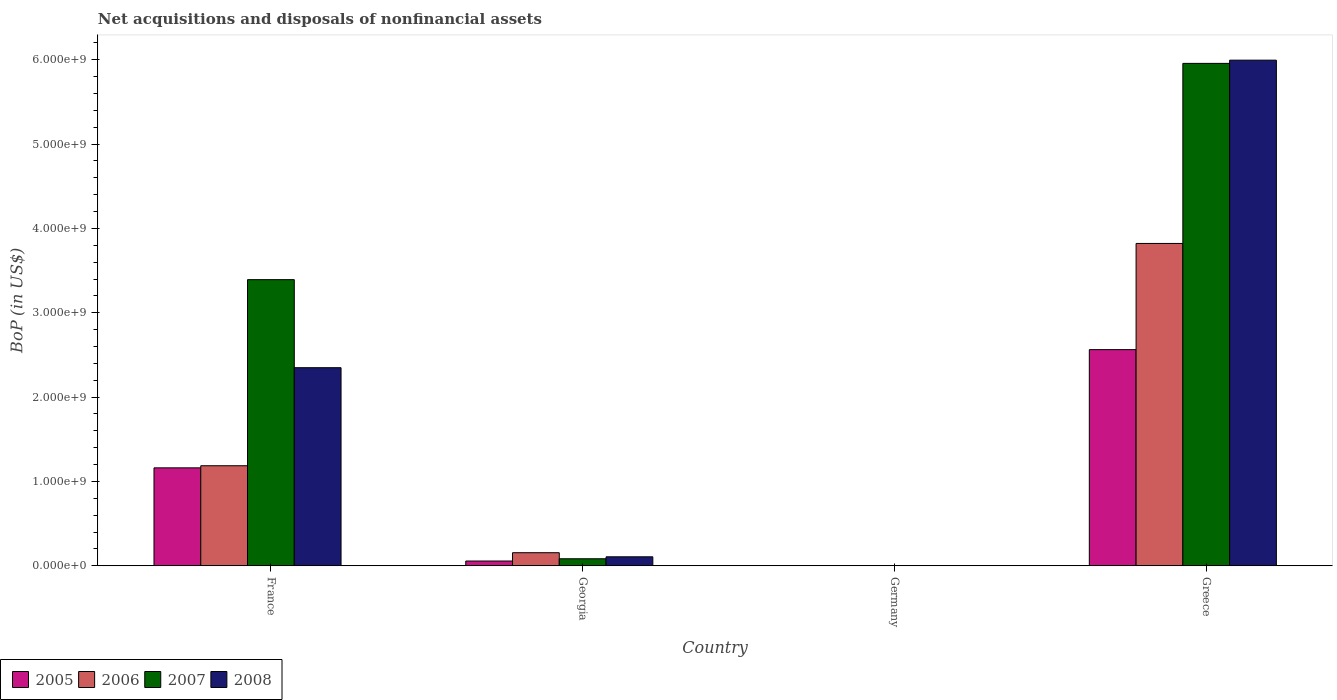Are the number of bars per tick equal to the number of legend labels?
Ensure brevity in your answer.  No. Are the number of bars on each tick of the X-axis equal?
Offer a very short reply. No. How many bars are there on the 4th tick from the right?
Your answer should be very brief. 4. What is the label of the 3rd group of bars from the left?
Provide a short and direct response. Germany. What is the Balance of Payments in 2005 in Georgia?
Make the answer very short. 5.65e+07. Across all countries, what is the maximum Balance of Payments in 2007?
Make the answer very short. 5.96e+09. In which country was the Balance of Payments in 2007 maximum?
Give a very brief answer. Greece. What is the total Balance of Payments in 2007 in the graph?
Your answer should be compact. 9.43e+09. What is the difference between the Balance of Payments in 2005 in France and that in Georgia?
Provide a short and direct response. 1.10e+09. What is the difference between the Balance of Payments in 2006 in France and the Balance of Payments in 2005 in Germany?
Ensure brevity in your answer.  1.19e+09. What is the average Balance of Payments in 2007 per country?
Give a very brief answer. 2.36e+09. What is the difference between the Balance of Payments of/in 2008 and Balance of Payments of/in 2005 in Georgia?
Ensure brevity in your answer.  5.01e+07. What is the ratio of the Balance of Payments in 2006 in Georgia to that in Greece?
Your answer should be compact. 0.04. What is the difference between the highest and the second highest Balance of Payments in 2006?
Provide a succinct answer. 1.03e+09. What is the difference between the highest and the lowest Balance of Payments in 2006?
Make the answer very short. 3.82e+09. In how many countries, is the Balance of Payments in 2006 greater than the average Balance of Payments in 2006 taken over all countries?
Keep it short and to the point. 1. How many bars are there?
Give a very brief answer. 12. Are all the bars in the graph horizontal?
Your answer should be very brief. No. How many countries are there in the graph?
Your response must be concise. 4. Are the values on the major ticks of Y-axis written in scientific E-notation?
Provide a short and direct response. Yes. Does the graph contain grids?
Offer a very short reply. No. What is the title of the graph?
Make the answer very short. Net acquisitions and disposals of nonfinancial assets. What is the label or title of the X-axis?
Your answer should be compact. Country. What is the label or title of the Y-axis?
Your answer should be very brief. BoP (in US$). What is the BoP (in US$) of 2005 in France?
Offer a terse response. 1.16e+09. What is the BoP (in US$) of 2006 in France?
Your response must be concise. 1.19e+09. What is the BoP (in US$) of 2007 in France?
Ensure brevity in your answer.  3.39e+09. What is the BoP (in US$) in 2008 in France?
Give a very brief answer. 2.35e+09. What is the BoP (in US$) in 2005 in Georgia?
Your response must be concise. 5.65e+07. What is the BoP (in US$) in 2006 in Georgia?
Your response must be concise. 1.55e+08. What is the BoP (in US$) in 2007 in Georgia?
Offer a very short reply. 8.34e+07. What is the BoP (in US$) of 2008 in Georgia?
Your answer should be compact. 1.07e+08. What is the BoP (in US$) in 2008 in Germany?
Make the answer very short. 0. What is the BoP (in US$) of 2005 in Greece?
Provide a succinct answer. 2.56e+09. What is the BoP (in US$) in 2006 in Greece?
Offer a very short reply. 3.82e+09. What is the BoP (in US$) of 2007 in Greece?
Offer a terse response. 5.96e+09. What is the BoP (in US$) in 2008 in Greece?
Offer a terse response. 6.00e+09. Across all countries, what is the maximum BoP (in US$) in 2005?
Offer a terse response. 2.56e+09. Across all countries, what is the maximum BoP (in US$) in 2006?
Your response must be concise. 3.82e+09. Across all countries, what is the maximum BoP (in US$) in 2007?
Give a very brief answer. 5.96e+09. Across all countries, what is the maximum BoP (in US$) in 2008?
Offer a terse response. 6.00e+09. Across all countries, what is the minimum BoP (in US$) in 2006?
Give a very brief answer. 0. Across all countries, what is the minimum BoP (in US$) of 2008?
Your answer should be compact. 0. What is the total BoP (in US$) in 2005 in the graph?
Provide a succinct answer. 3.78e+09. What is the total BoP (in US$) in 2006 in the graph?
Ensure brevity in your answer.  5.16e+09. What is the total BoP (in US$) in 2007 in the graph?
Make the answer very short. 9.43e+09. What is the total BoP (in US$) of 2008 in the graph?
Ensure brevity in your answer.  8.45e+09. What is the difference between the BoP (in US$) of 2005 in France and that in Georgia?
Offer a terse response. 1.10e+09. What is the difference between the BoP (in US$) in 2006 in France and that in Georgia?
Provide a short and direct response. 1.03e+09. What is the difference between the BoP (in US$) of 2007 in France and that in Georgia?
Ensure brevity in your answer.  3.31e+09. What is the difference between the BoP (in US$) in 2008 in France and that in Georgia?
Ensure brevity in your answer.  2.24e+09. What is the difference between the BoP (in US$) of 2005 in France and that in Greece?
Your answer should be compact. -1.40e+09. What is the difference between the BoP (in US$) in 2006 in France and that in Greece?
Your answer should be compact. -2.64e+09. What is the difference between the BoP (in US$) in 2007 in France and that in Greece?
Give a very brief answer. -2.56e+09. What is the difference between the BoP (in US$) of 2008 in France and that in Greece?
Make the answer very short. -3.65e+09. What is the difference between the BoP (in US$) of 2005 in Georgia and that in Greece?
Your answer should be very brief. -2.51e+09. What is the difference between the BoP (in US$) of 2006 in Georgia and that in Greece?
Your answer should be compact. -3.67e+09. What is the difference between the BoP (in US$) of 2007 in Georgia and that in Greece?
Provide a succinct answer. -5.87e+09. What is the difference between the BoP (in US$) of 2008 in Georgia and that in Greece?
Ensure brevity in your answer.  -5.89e+09. What is the difference between the BoP (in US$) of 2005 in France and the BoP (in US$) of 2006 in Georgia?
Provide a short and direct response. 1.01e+09. What is the difference between the BoP (in US$) in 2005 in France and the BoP (in US$) in 2007 in Georgia?
Provide a short and direct response. 1.08e+09. What is the difference between the BoP (in US$) of 2005 in France and the BoP (in US$) of 2008 in Georgia?
Give a very brief answer. 1.05e+09. What is the difference between the BoP (in US$) of 2006 in France and the BoP (in US$) of 2007 in Georgia?
Provide a short and direct response. 1.10e+09. What is the difference between the BoP (in US$) in 2006 in France and the BoP (in US$) in 2008 in Georgia?
Your answer should be very brief. 1.08e+09. What is the difference between the BoP (in US$) in 2007 in France and the BoP (in US$) in 2008 in Georgia?
Offer a very short reply. 3.29e+09. What is the difference between the BoP (in US$) of 2005 in France and the BoP (in US$) of 2006 in Greece?
Offer a very short reply. -2.66e+09. What is the difference between the BoP (in US$) of 2005 in France and the BoP (in US$) of 2007 in Greece?
Ensure brevity in your answer.  -4.80e+09. What is the difference between the BoP (in US$) in 2005 in France and the BoP (in US$) in 2008 in Greece?
Your response must be concise. -4.83e+09. What is the difference between the BoP (in US$) in 2006 in France and the BoP (in US$) in 2007 in Greece?
Provide a short and direct response. -4.77e+09. What is the difference between the BoP (in US$) in 2006 in France and the BoP (in US$) in 2008 in Greece?
Give a very brief answer. -4.81e+09. What is the difference between the BoP (in US$) of 2007 in France and the BoP (in US$) of 2008 in Greece?
Your response must be concise. -2.60e+09. What is the difference between the BoP (in US$) of 2005 in Georgia and the BoP (in US$) of 2006 in Greece?
Your answer should be compact. -3.77e+09. What is the difference between the BoP (in US$) of 2005 in Georgia and the BoP (in US$) of 2007 in Greece?
Keep it short and to the point. -5.90e+09. What is the difference between the BoP (in US$) in 2005 in Georgia and the BoP (in US$) in 2008 in Greece?
Offer a very short reply. -5.94e+09. What is the difference between the BoP (in US$) in 2006 in Georgia and the BoP (in US$) in 2007 in Greece?
Your response must be concise. -5.80e+09. What is the difference between the BoP (in US$) of 2006 in Georgia and the BoP (in US$) of 2008 in Greece?
Keep it short and to the point. -5.84e+09. What is the difference between the BoP (in US$) of 2007 in Georgia and the BoP (in US$) of 2008 in Greece?
Offer a very short reply. -5.91e+09. What is the average BoP (in US$) of 2005 per country?
Make the answer very short. 9.45e+08. What is the average BoP (in US$) in 2006 per country?
Make the answer very short. 1.29e+09. What is the average BoP (in US$) of 2007 per country?
Provide a succinct answer. 2.36e+09. What is the average BoP (in US$) in 2008 per country?
Offer a very short reply. 2.11e+09. What is the difference between the BoP (in US$) in 2005 and BoP (in US$) in 2006 in France?
Your response must be concise. -2.51e+07. What is the difference between the BoP (in US$) in 2005 and BoP (in US$) in 2007 in France?
Offer a terse response. -2.23e+09. What is the difference between the BoP (in US$) in 2005 and BoP (in US$) in 2008 in France?
Offer a very short reply. -1.19e+09. What is the difference between the BoP (in US$) of 2006 and BoP (in US$) of 2007 in France?
Make the answer very short. -2.21e+09. What is the difference between the BoP (in US$) in 2006 and BoP (in US$) in 2008 in France?
Your answer should be compact. -1.16e+09. What is the difference between the BoP (in US$) in 2007 and BoP (in US$) in 2008 in France?
Ensure brevity in your answer.  1.04e+09. What is the difference between the BoP (in US$) of 2005 and BoP (in US$) of 2006 in Georgia?
Provide a short and direct response. -9.86e+07. What is the difference between the BoP (in US$) in 2005 and BoP (in US$) in 2007 in Georgia?
Your response must be concise. -2.69e+07. What is the difference between the BoP (in US$) in 2005 and BoP (in US$) in 2008 in Georgia?
Provide a succinct answer. -5.01e+07. What is the difference between the BoP (in US$) in 2006 and BoP (in US$) in 2007 in Georgia?
Your response must be concise. 7.17e+07. What is the difference between the BoP (in US$) in 2006 and BoP (in US$) in 2008 in Georgia?
Make the answer very short. 4.85e+07. What is the difference between the BoP (in US$) of 2007 and BoP (in US$) of 2008 in Georgia?
Ensure brevity in your answer.  -2.32e+07. What is the difference between the BoP (in US$) in 2005 and BoP (in US$) in 2006 in Greece?
Give a very brief answer. -1.26e+09. What is the difference between the BoP (in US$) in 2005 and BoP (in US$) in 2007 in Greece?
Offer a very short reply. -3.39e+09. What is the difference between the BoP (in US$) in 2005 and BoP (in US$) in 2008 in Greece?
Your answer should be very brief. -3.43e+09. What is the difference between the BoP (in US$) of 2006 and BoP (in US$) of 2007 in Greece?
Give a very brief answer. -2.14e+09. What is the difference between the BoP (in US$) in 2006 and BoP (in US$) in 2008 in Greece?
Offer a terse response. -2.17e+09. What is the difference between the BoP (in US$) in 2007 and BoP (in US$) in 2008 in Greece?
Offer a very short reply. -3.82e+07. What is the ratio of the BoP (in US$) in 2005 in France to that in Georgia?
Keep it short and to the point. 20.56. What is the ratio of the BoP (in US$) of 2006 in France to that in Georgia?
Your response must be concise. 7.65. What is the ratio of the BoP (in US$) of 2007 in France to that in Georgia?
Your answer should be very brief. 40.68. What is the ratio of the BoP (in US$) in 2008 in France to that in Georgia?
Keep it short and to the point. 22.03. What is the ratio of the BoP (in US$) in 2005 in France to that in Greece?
Your response must be concise. 0.45. What is the ratio of the BoP (in US$) in 2006 in France to that in Greece?
Ensure brevity in your answer.  0.31. What is the ratio of the BoP (in US$) of 2007 in France to that in Greece?
Keep it short and to the point. 0.57. What is the ratio of the BoP (in US$) of 2008 in France to that in Greece?
Offer a very short reply. 0.39. What is the ratio of the BoP (in US$) in 2005 in Georgia to that in Greece?
Provide a short and direct response. 0.02. What is the ratio of the BoP (in US$) in 2006 in Georgia to that in Greece?
Provide a succinct answer. 0.04. What is the ratio of the BoP (in US$) in 2007 in Georgia to that in Greece?
Ensure brevity in your answer.  0.01. What is the ratio of the BoP (in US$) in 2008 in Georgia to that in Greece?
Give a very brief answer. 0.02. What is the difference between the highest and the second highest BoP (in US$) of 2005?
Your answer should be very brief. 1.40e+09. What is the difference between the highest and the second highest BoP (in US$) of 2006?
Offer a very short reply. 2.64e+09. What is the difference between the highest and the second highest BoP (in US$) of 2007?
Your answer should be very brief. 2.56e+09. What is the difference between the highest and the second highest BoP (in US$) in 2008?
Offer a very short reply. 3.65e+09. What is the difference between the highest and the lowest BoP (in US$) in 2005?
Make the answer very short. 2.56e+09. What is the difference between the highest and the lowest BoP (in US$) of 2006?
Make the answer very short. 3.82e+09. What is the difference between the highest and the lowest BoP (in US$) in 2007?
Give a very brief answer. 5.96e+09. What is the difference between the highest and the lowest BoP (in US$) in 2008?
Provide a short and direct response. 6.00e+09. 